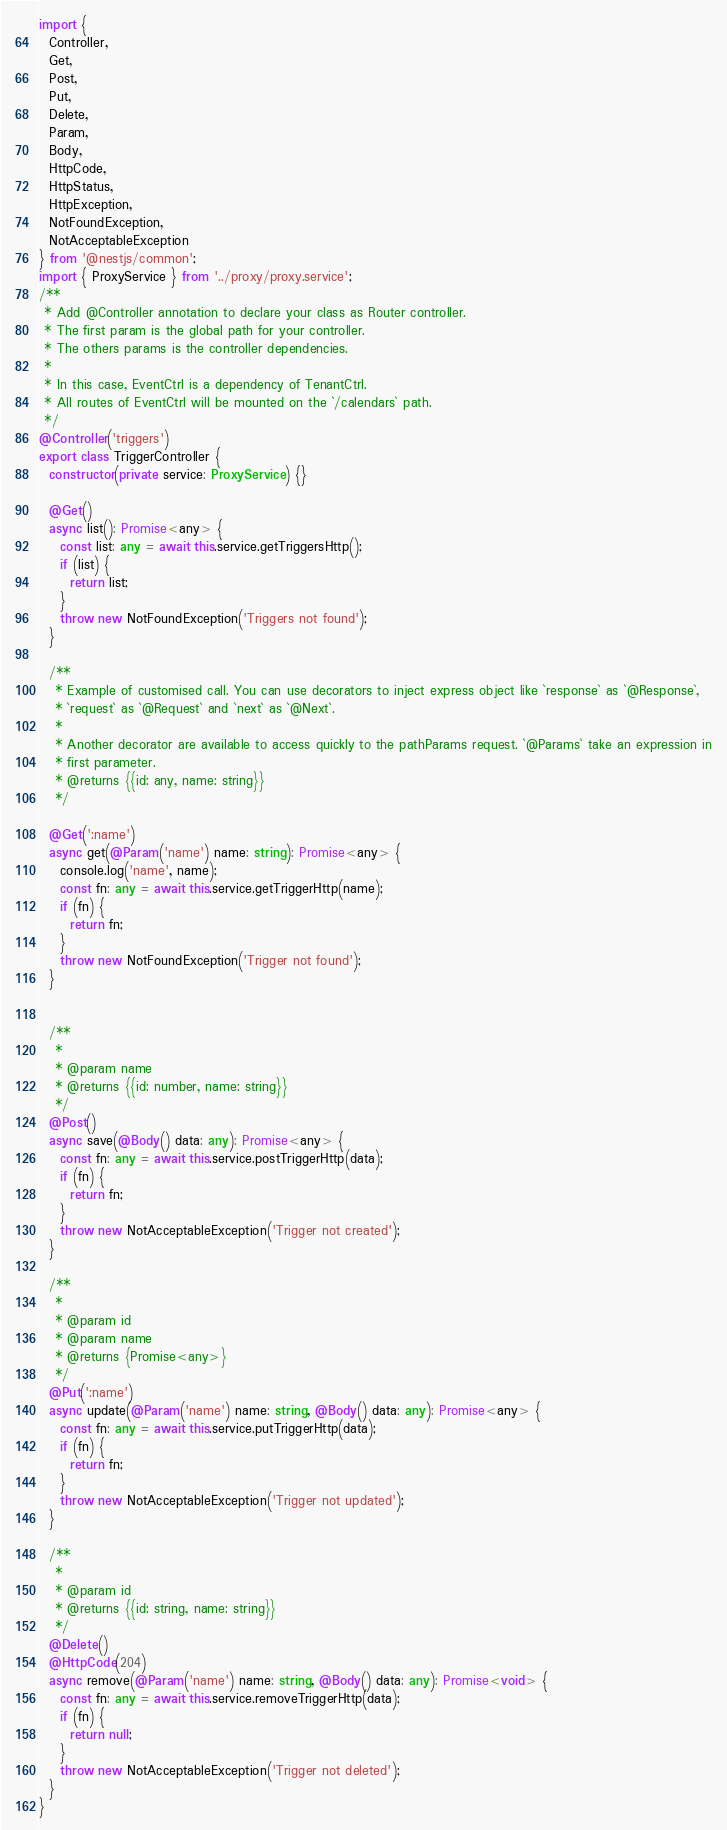Convert code to text. <code><loc_0><loc_0><loc_500><loc_500><_TypeScript_>import {
  Controller,
  Get,
  Post,
  Put,
  Delete,
  Param,
  Body,
  HttpCode,
  HttpStatus,
  HttpException,
  NotFoundException,
  NotAcceptableException
} from '@nestjs/common';
import { ProxyService } from '../proxy/proxy.service';
/**
 * Add @Controller annotation to declare your class as Router controller.
 * The first param is the global path for your controller.
 * The others params is the controller dependencies.
 *
 * In this case, EventCtrl is a dependency of TenantCtrl.
 * All routes of EventCtrl will be mounted on the `/calendars` path.
 */
@Controller('triggers')
export class TriggerController {
  constructor(private service: ProxyService) {}

  @Get()
  async list(): Promise<any> {
    const list: any = await this.service.getTriggersHttp();
    if (list) {
      return list;
    }
    throw new NotFoundException('Triggers not found');
  }

  /**
   * Example of customised call. You can use decorators to inject express object like `response` as `@Response`,
   * `request` as `@Request` and `next` as `@Next`.
   *
   * Another decorator are available to access quickly to the pathParams request. `@Params` take an expression in
   * first parameter.
   * @returns {{id: any, name: string}}
   */

  @Get(':name')
  async get(@Param('name') name: string): Promise<any> {
    console.log('name', name);
    const fn: any = await this.service.getTriggerHttp(name);
    if (fn) {
      return fn;
    }
    throw new NotFoundException('Trigger not found');
  }


  /**
   *
   * @param name
   * @returns {{id: number, name: string}}
   */
  @Post()
  async save(@Body() data: any): Promise<any> {
    const fn: any = await this.service.postTriggerHttp(data);
    if (fn) {
      return fn;
    }
    throw new NotAcceptableException('Trigger not created');
  }

  /**
   *
   * @param id
   * @param name
   * @returns {Promise<any>}
   */
  @Put(':name')
  async update(@Param('name') name: string, @Body() data: any): Promise<any> {
    const fn: any = await this.service.putTriggerHttp(data);
    if (fn) {
      return fn;
    }
    throw new NotAcceptableException('Trigger not updated');
  }

  /**
   *
   * @param id
   * @returns {{id: string, name: string}}
   */
  @Delete()
  @HttpCode(204)
  async remove(@Param('name') name: string, @Body() data: any): Promise<void> {
    const fn: any = await this.service.removeTriggerHttp(data);
    if (fn) {
      return null;
    }
    throw new NotAcceptableException('Trigger not deleted');
  }
}
</code> 